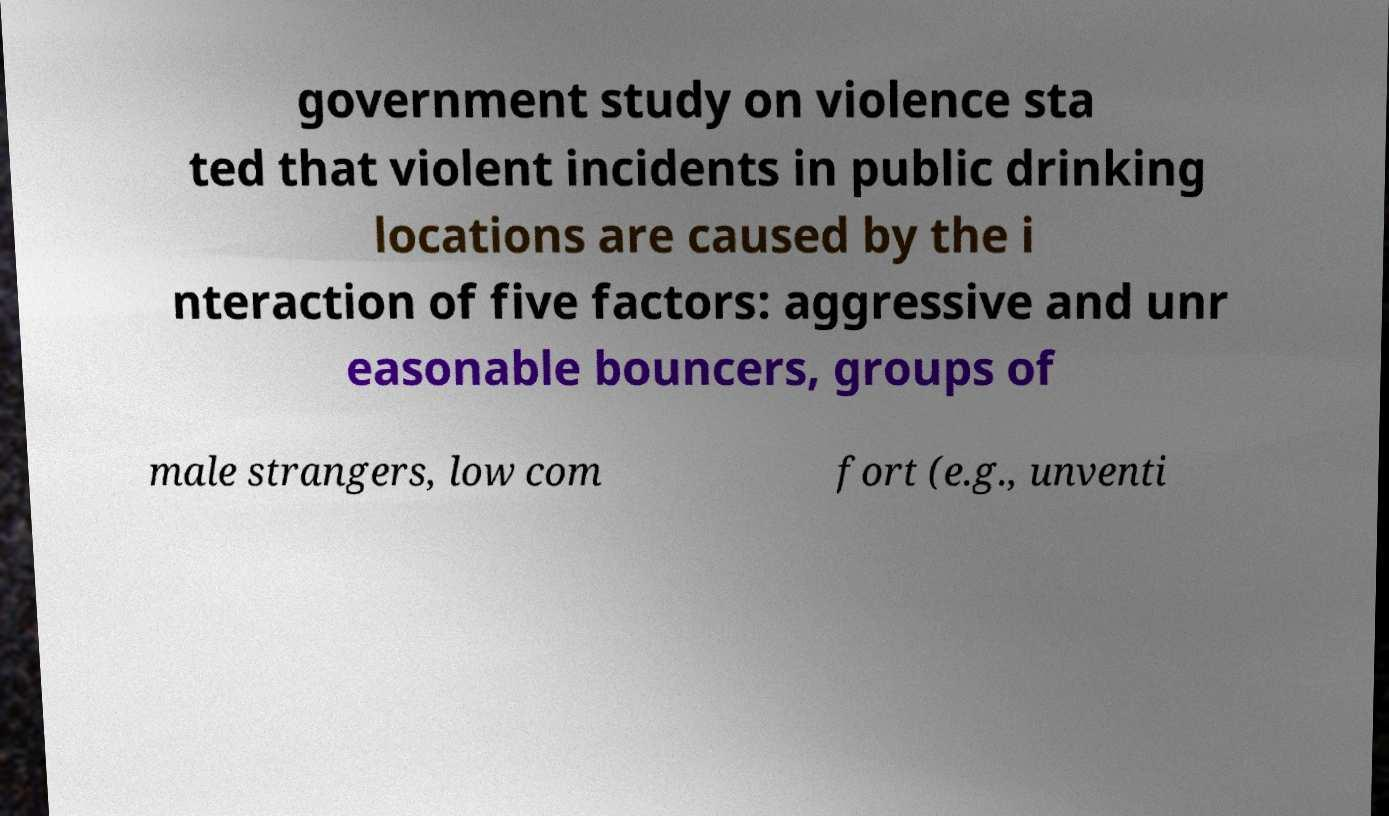Please read and relay the text visible in this image. What does it say? government study on violence sta ted that violent incidents in public drinking locations are caused by the i nteraction of five factors: aggressive and unr easonable bouncers, groups of male strangers, low com fort (e.g., unventi 